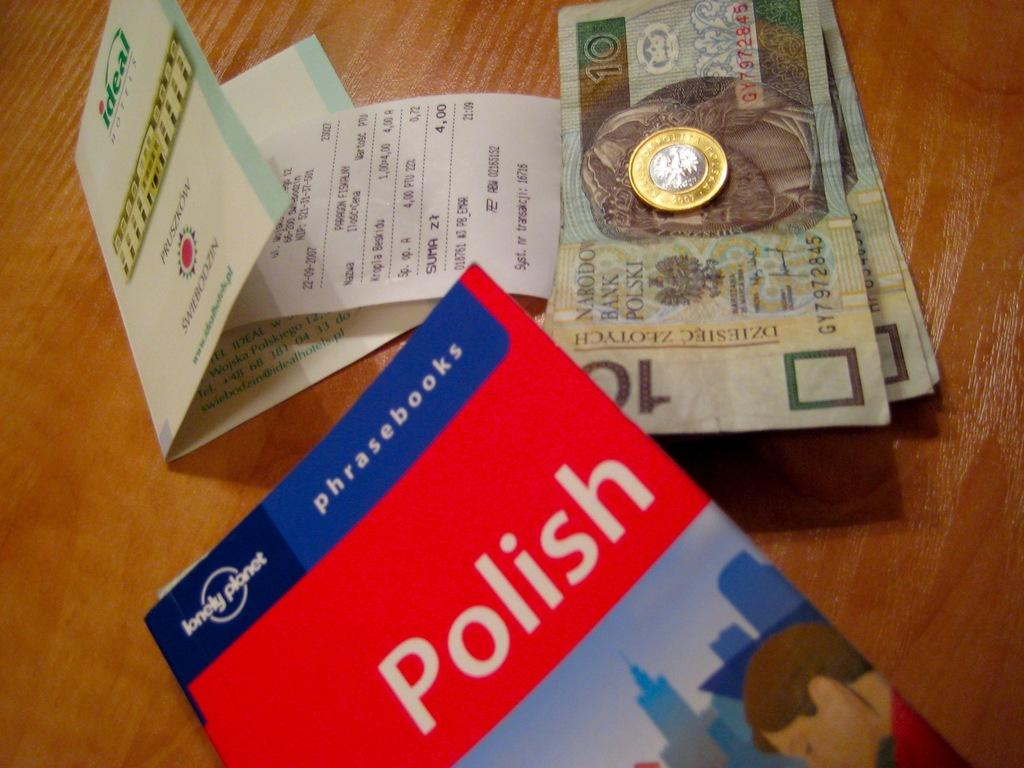<image>
Present a compact description of the photo's key features. the word Polish is on a red book 